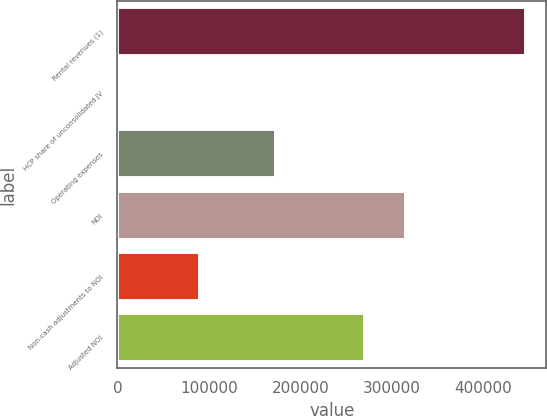Convert chart. <chart><loc_0><loc_0><loc_500><loc_500><bar_chart><fcel>Rental revenues (1)<fcel>HCP share of unconsolidated JV<fcel>Operating expenses<fcel>NOI<fcel>Non-cash adjustments to NOI<fcel>Adjusted NOI<nl><fcel>446280<fcel>595<fcel>173687<fcel>315006<fcel>89732<fcel>270437<nl></chart> 